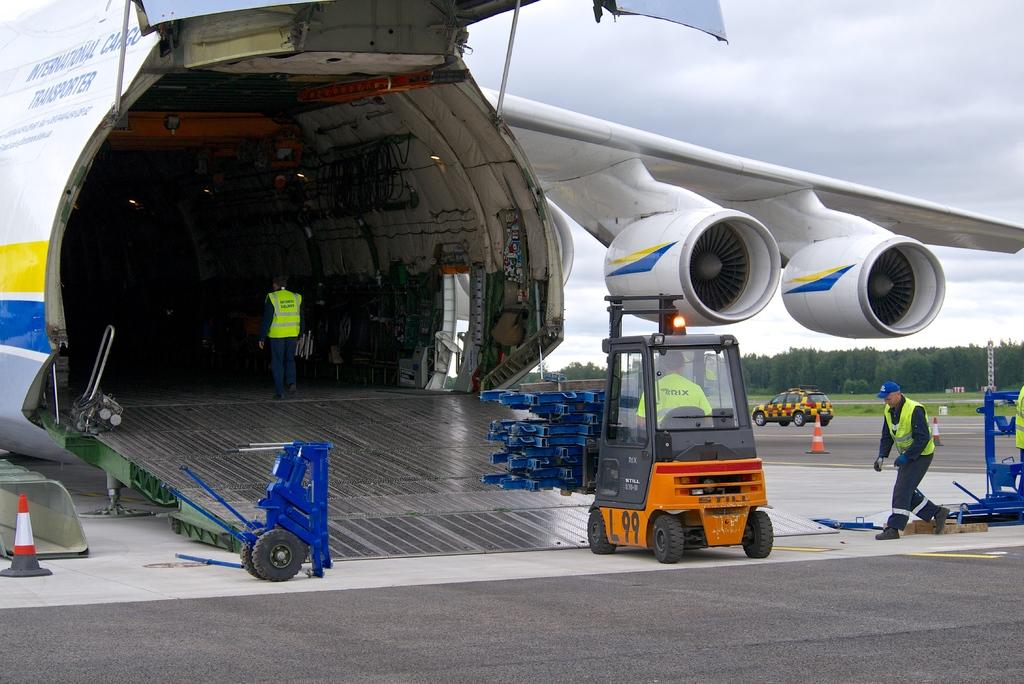<image>
Render a clear and concise summary of the photo. International Cargo Transporter logo on a airplane in blue writing. 